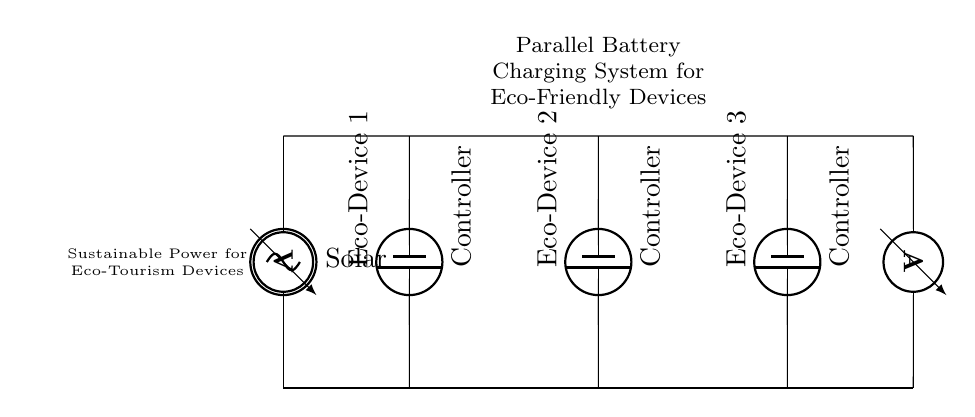What is the source of power in this circuit? The circuit diagram indicates a solar panel as the power source, labeled as "Solar."
Answer: Solar panel How many eco-friendly devices are being charged? There are three batteries connected to the charging controllers, each representing an eco-friendly device.
Answer: Three What type of circuit is represented here? This is a parallel charging system, where multiple devices are charged simultaneously while sharing the same voltage source.
Answer: Parallel What is the role of the charging controllers in this circuit? The charging controllers manage the charging process for each eco-device and ensure proper energy allocation from the solar panel.
Answer: Energy management What is the function of the ammeter in this circuit? The ammeter measures the current flowing through the circuit, providing feedback on the charging status of the battery system.
Answer: Current measurement If one device is removed, how will it affect the others? In a parallel circuit, removing one device will not affect the others, as each device has its own separate branch for current.
Answer: No effect 